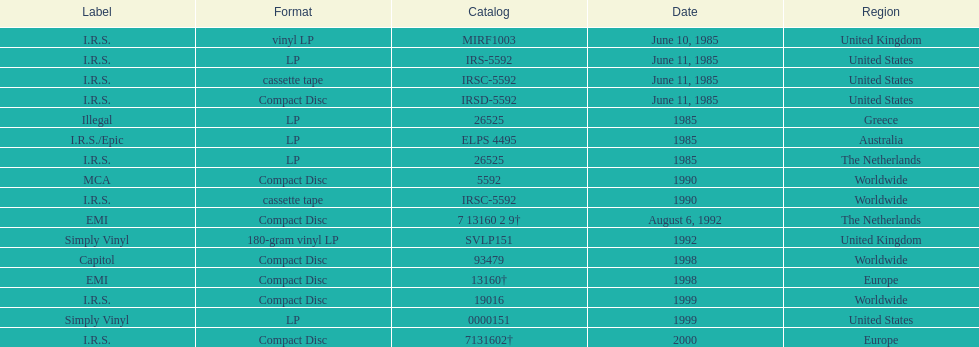How many more releases were in compact disc format than cassette tape? 5. 